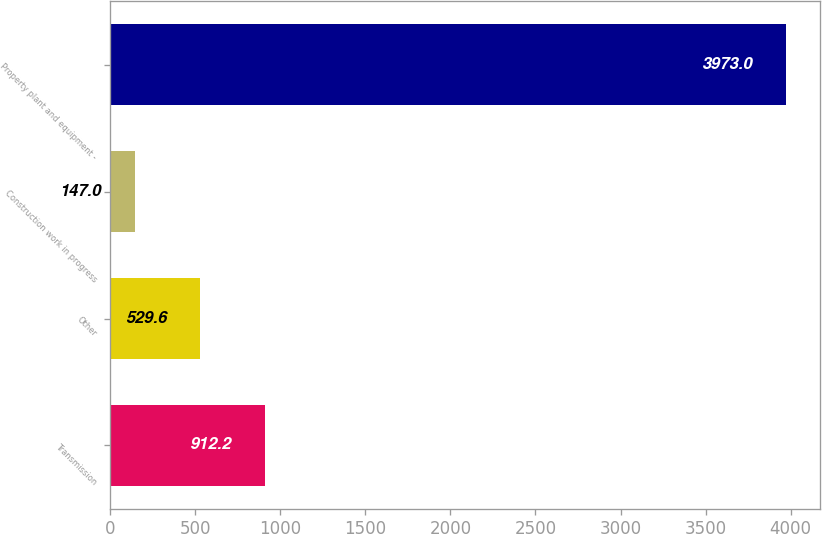<chart> <loc_0><loc_0><loc_500><loc_500><bar_chart><fcel>Transmission<fcel>Other<fcel>Construction work in progress<fcel>Property plant and equipment -<nl><fcel>912.2<fcel>529.6<fcel>147<fcel>3973<nl></chart> 